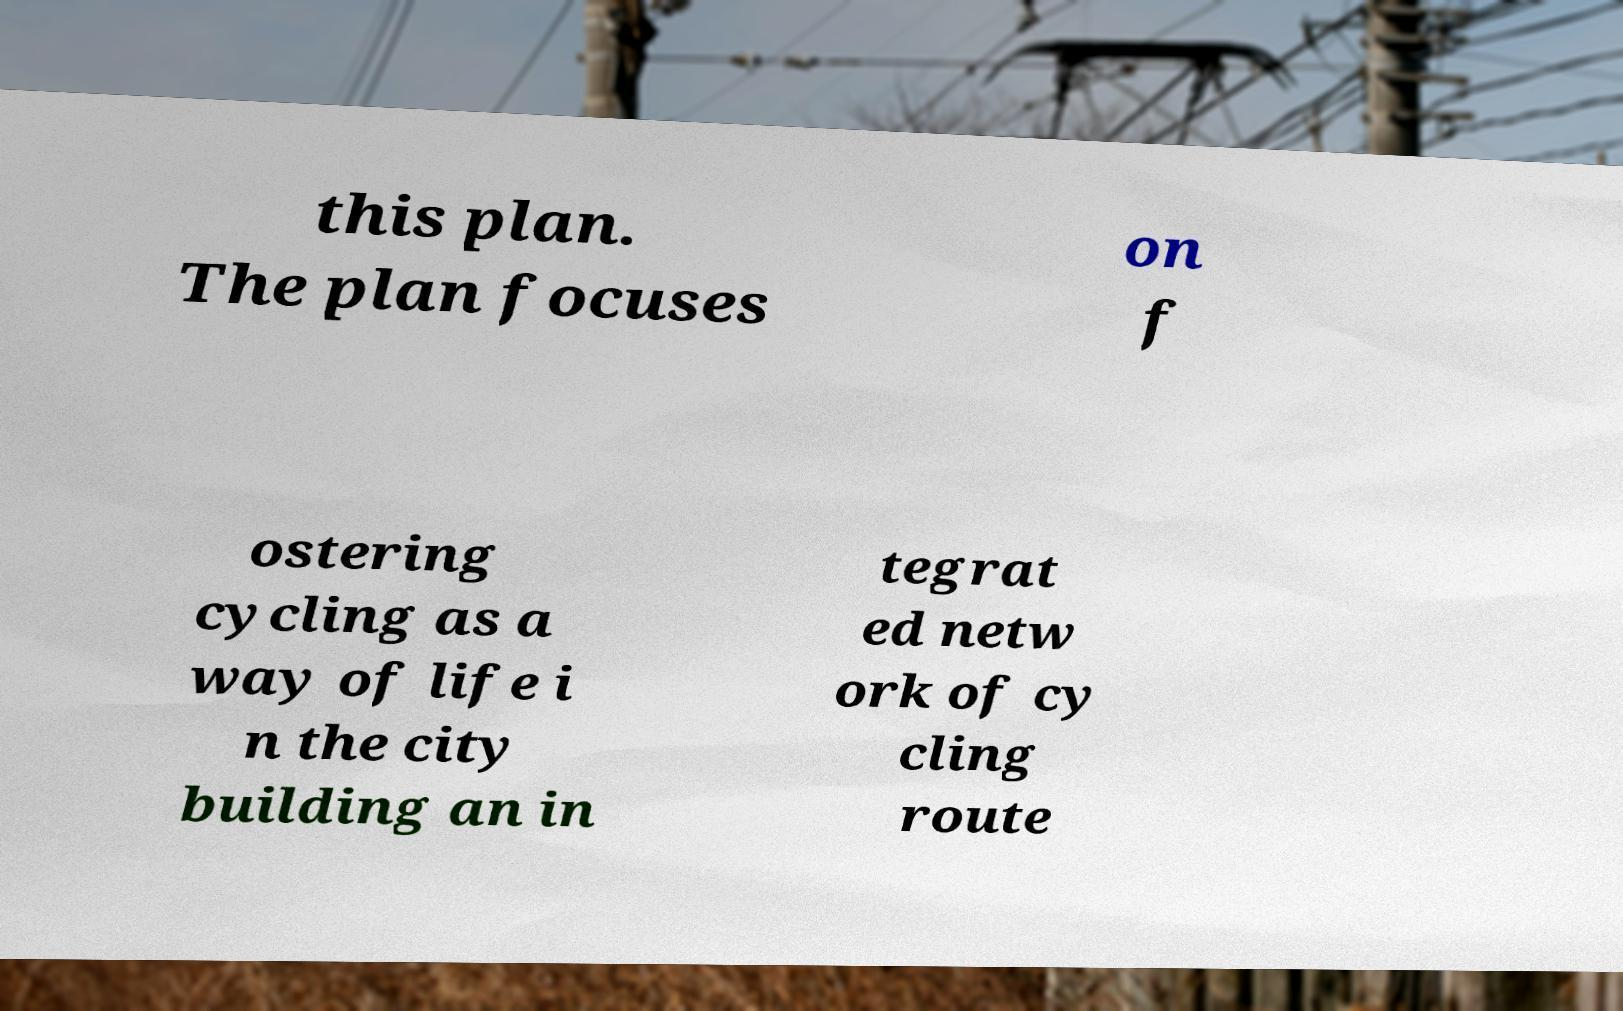Please read and relay the text visible in this image. What does it say? this plan. The plan focuses on f ostering cycling as a way of life i n the city building an in tegrat ed netw ork of cy cling route 